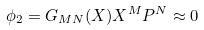<formula> <loc_0><loc_0><loc_500><loc_500>\phi _ { 2 } = G _ { M N } ( X ) X ^ { M } P ^ { N } \approx 0</formula> 